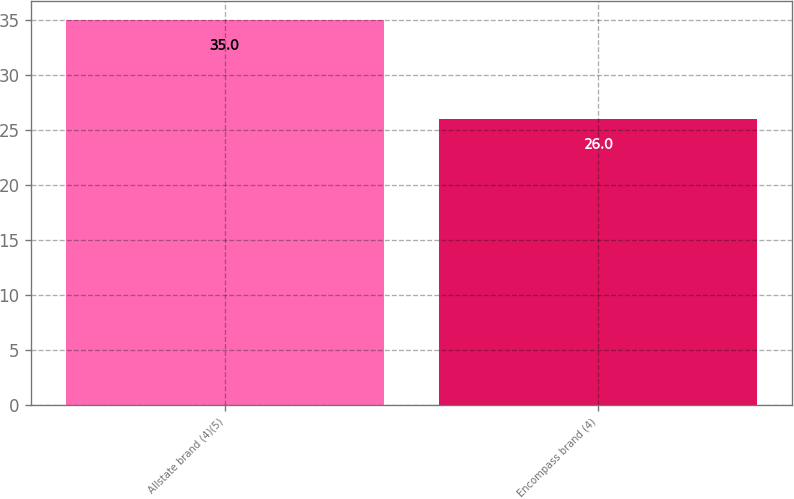<chart> <loc_0><loc_0><loc_500><loc_500><bar_chart><fcel>Allstate brand (4)(5)<fcel>Encompass brand (4)<nl><fcel>35<fcel>26<nl></chart> 